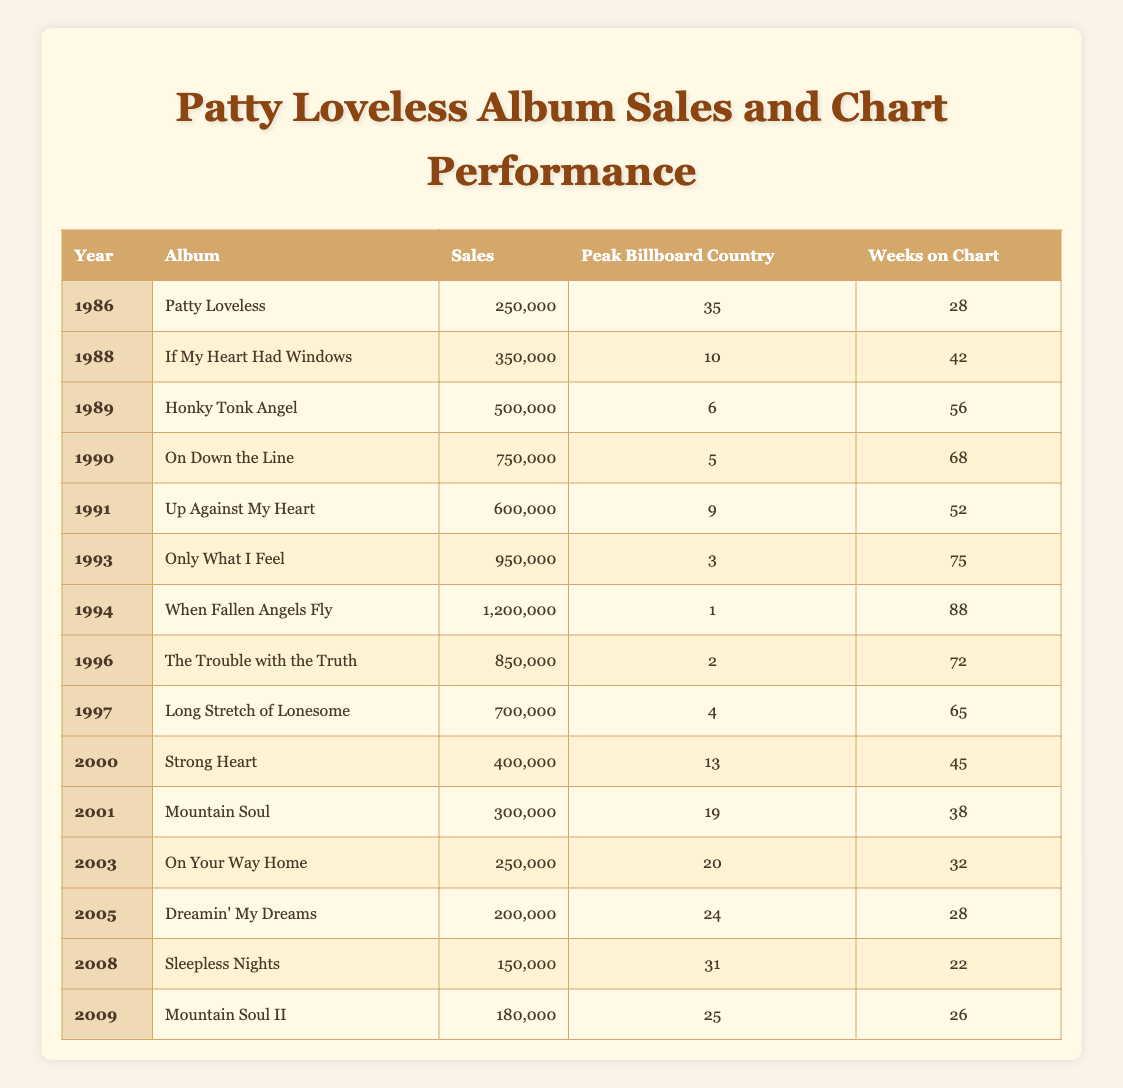What year did Patty Loveless release her debut album? The debut album is titled "Patty Loveless" and is listed in the year 1986 in the table.
Answer: 1986 What was the peak Billboard Country chart position for "When Fallen Angels Fly"? The table indicates that "When Fallen Angels Fly," released in 1994, reached the peak position of 1 on the Billboard Country chart.
Answer: 1 How many weeks did "Only What I Feel" stay on the chart? According to the table, "Only What I Feel" had a total of 75 weeks on the chart.
Answer: 75 Which album had the highest sales and what were those sales? The album with the highest sales is "When Fallen Angels Fly," with total sales of 1,200,000 units.
Answer: 1,200,000 In what year did Patty Loveless achieve her highest sales? By reviewing the sales figures in the table, it is evident that 1994 had the highest sales at 1,200,000 for the album "When Fallen Angels Fly."
Answer: 1994 What is the average number of weeks on the chart for albums released after 2000? The albums released after 2000 are "Strong Heart" (45 weeks), "Mountain Soul" (38 weeks), "On Your Way Home" (32 weeks), "Dreamin' My Dreams" (28 weeks), "Sleepless Nights" (22 weeks), and "Mountain Soul II" (26 weeks). Adding them up gives 45 + 38 + 32 + 28 + 22 + 26 = 191 weeks. Dividing by 6 gives an average of 31.83 weeks, which can be rounded to 32 weeks.
Answer: 32 Did Patty Loveless have any albums that sold less than 200,000 copies? After examining the sales figures in the table, it is clear that the lowest sales reported for "Dreamin' My Dreams," "Sleepless Nights," and "Mountain Soul II" are 200,000 or above. Thus, no albums sold less than 200,000 units.
Answer: No Which album had the most weeks on the chart and how many weeks did it stay there? The album "When Fallen Angels Fly" had the most weeks on the chart with a total of 88 weeks, as indicated in the table.
Answer: 88 How many albums reached the Top 10 of the Billboard Country chart? From the table, the albums that reached the Top 10 are "If My Heart Had Windows" (10), "Honky Tonk Angel" (6), "On Down the Line" (5), and "Up Against My Heart" (9). That is a total of 4 albums in the Top 10.
Answer: 4 What is the total sales of Patty Loveless' albums between 1986 and 1994? To find the total sales, we sum the sales from each year within that range: 250,000 (1986) + 350,000 (1988) + 500,000 (1989) + 750,000 (1990) + 600,000 (1991) + 950,000 (1993) + 1,200,000 (1994) = 3,600,000.
Answer: 3,600,000 